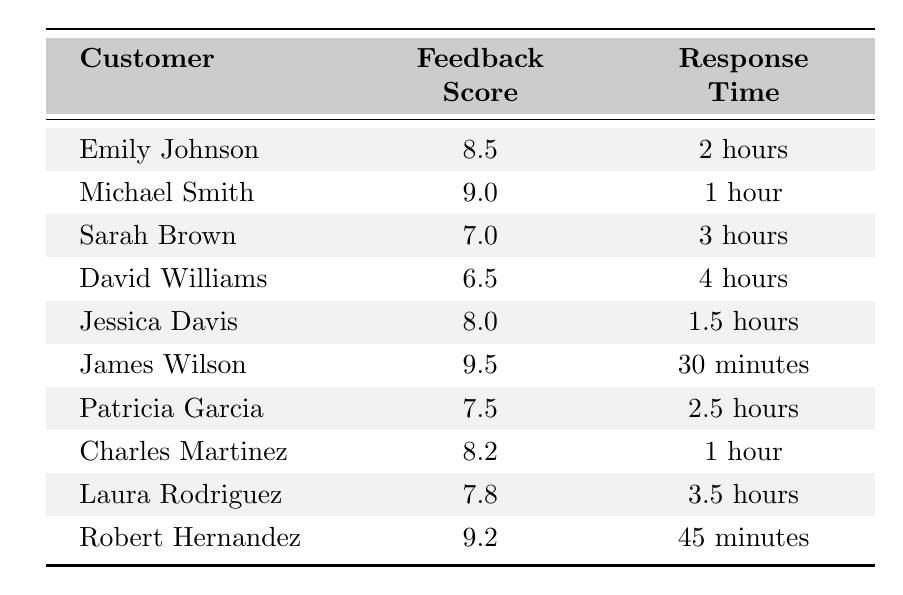What is the feedback score of Jessica Davis? The table shows that Jessica Davis has a feedback score listed under the "Feedback Score" column, which is 8.0.
Answer: 8.0 Who had the fastest response time and how long was it? James Wilson is listed with the fastest response time of 30 minutes in the "Response Time" column.
Answer: James Wilson, 30 minutes What is the average feedback score of all customers? First, I will sum the feedback scores: 8.5 + 9.0 + 7.0 + 6.5 + 8.0 + 9.5 + 7.5 + 8.2 + 7.8 + 9.2 = 81.2. There are 10 customers, so the average is 81.2 / 10 = 8.12.
Answer: 8.12 How many customers had a feedback score higher than 8.0? I will count the entries in the "Feedback Score" column that are greater than 8.0: Michael Smith (9.0), James Wilson (9.5), Robert Hernandez (9.2), and Emily Johnson (8.5) gives us four customers total.
Answer: 4 Was there any customer with a feedback score lower than 7.0? The feedback score for David Williams is lower than 7.0, as he has a score of 6.5, confirming that there is a customer with a lower score.
Answer: Yes What is the median response time among all customers? First, I will convert all response times to hours for comparison: James Wilson: 0.5, Michael Smith: 1, Charles Martinez: 1, Jessica Davis: 1.5, Emily Johnson: 2, Patricia Garcia: 2.5, Sarah Brown: 3, Laura Rodriguez: 3.5, Robert Hernandez: 0.75, David Williams: 4. Now, in ascending order, the times are: 0.5, 0.75, 1, 1, 1.5, 2, 2.5, 3, 3.5, 4. The median is between the 5th and 6th entries: (1.5 + 2) / 2 = 1.75 hours.
Answer: 1.75 hours Which customer had a feedback score of 9.2? The table shows that Robert Hernandez is associated with a feedback score of 9.2.
Answer: Robert Hernandez Who took longer to respond, Sarah Brown or Laura Rodriguez? Comparing the "Response Time" values, Sarah Brown has 3 hours, and Laura Rodriguez has 3.5 hours. Since 3.5 hours is more than 3 hours, Laura Rodriguez took longer to respond.
Answer: Laura Rodriguez How many customers had a response time of more than 2 hours? I will count the response times listed in the "Response Time" column that are greater than 2 hours: Sarah Brown (3 hours), David Williams (4 hours), Patricia Garcia (2.5 hours), and Laura Rodriguez (3.5 hours), giving us four customers.
Answer: 4 Is the average feedback score above 8.0? The previously calculated average feedback score is 8.12, which is indeed greater than 8.0, confirming the statement.
Answer: Yes 